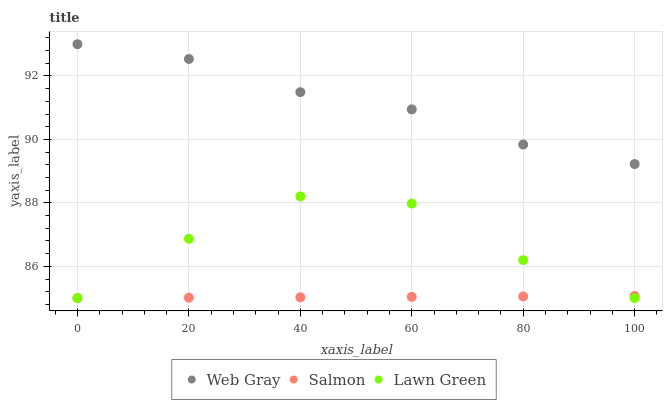Does Salmon have the minimum area under the curve?
Answer yes or no. Yes. Does Web Gray have the maximum area under the curve?
Answer yes or no. Yes. Does Web Gray have the minimum area under the curve?
Answer yes or no. No. Does Salmon have the maximum area under the curve?
Answer yes or no. No. Is Salmon the smoothest?
Answer yes or no. Yes. Is Lawn Green the roughest?
Answer yes or no. Yes. Is Web Gray the smoothest?
Answer yes or no. No. Is Web Gray the roughest?
Answer yes or no. No. Does Lawn Green have the lowest value?
Answer yes or no. Yes. Does Web Gray have the lowest value?
Answer yes or no. No. Does Web Gray have the highest value?
Answer yes or no. Yes. Does Salmon have the highest value?
Answer yes or no. No. Is Salmon less than Web Gray?
Answer yes or no. Yes. Is Web Gray greater than Lawn Green?
Answer yes or no. Yes. Does Lawn Green intersect Salmon?
Answer yes or no. Yes. Is Lawn Green less than Salmon?
Answer yes or no. No. Is Lawn Green greater than Salmon?
Answer yes or no. No. Does Salmon intersect Web Gray?
Answer yes or no. No. 